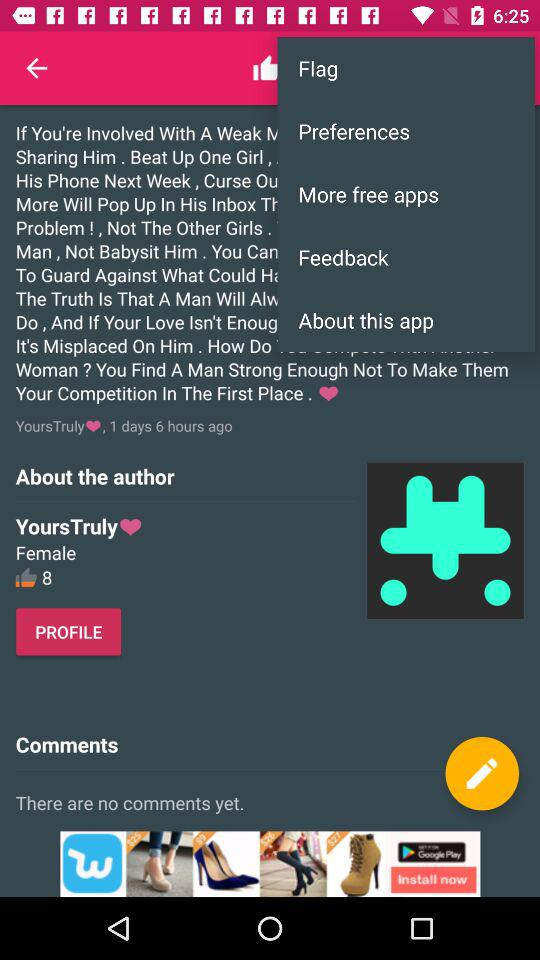How many likes are there for the author? There are 8 likes for the author. 